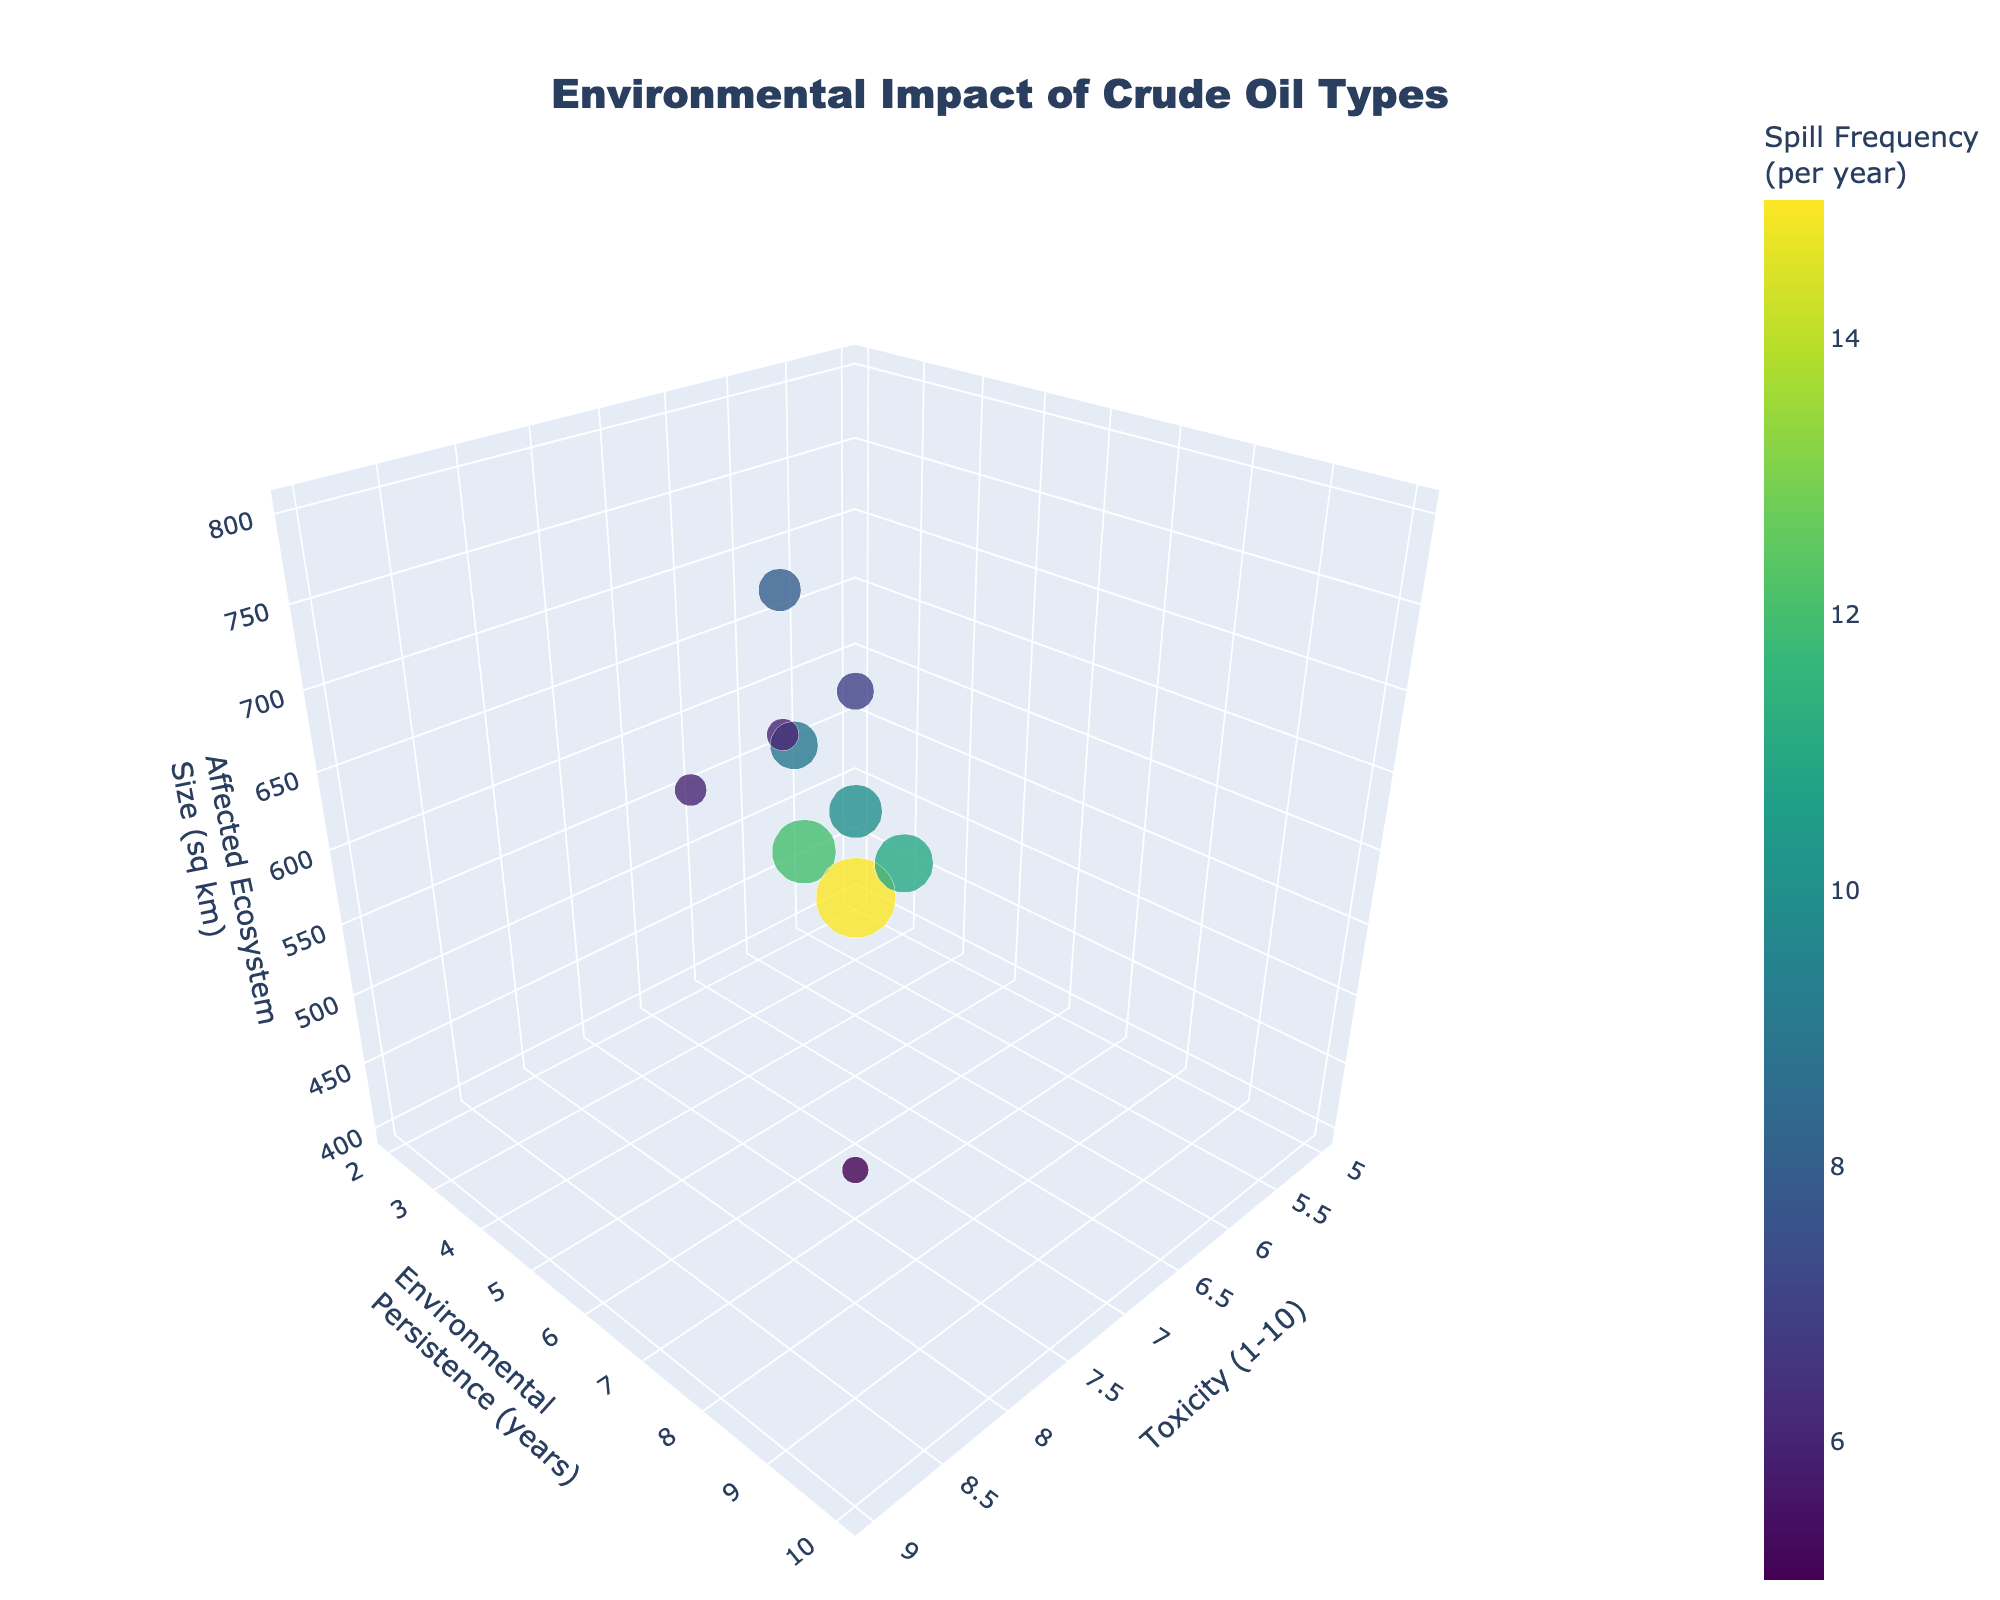What is the title of the figure? The title is clearly displayed at the top center of the figure.
Answer: Environmental Impact of Crude Oil Types Which crude oil type has the highest toxicity? By examining the x-axis labeled "Toxicity (1-10)", the data point furthest to the right represents the highest toxicity.
Answer: Bitumen What is the environmental persistence of the crude oil type with the highest spill frequency? Locate the largest bubble, then refer to its y-axis position labeled "Environmental Persistence (years)".
Answer: West Texas Intermediate has 2 years Which crude oil type affects the largest ecosystem size and what is that size? By examining the z-axis labeled "Affected Ecosystem Size (sq km)", the data point with the highest value is identified.
Answer: Heavy Sour Crude, 800 sq km Which crude oil type has lower toxicity, Nigerian Bonny Light or Brent Crude? Compare the positions along the x-axis for these two oil types. Nigerian Bonny Light is at x=5 and Brent Crude at x=6.
Answer: Nigerian Bonny Light What is the average environmental persistence of Brent Crude and Saudi Arabian Light? Average their y-axis values: (4+5)/2 = 4.5.
Answer: 4.5 years How does the spill frequency of Iranian Heavy compare to Bitumen? Compare the size of the bubbles representing these oil types; larger bubbles indicate higher frequency.
Answer: Iranian Heavy has a higher spill frequency than Bitumen What is the relationship between toxicity and affected ecosystem size for Venezuelan Extra Heavy? Locate the Venezuelan Extra Heavy bubble and note its x and z positions: x=9 (high toxicity), z=750 (large ecosystem size).
Answer: High toxicity and large affected area Is there any crude oil type that has low toxicity but high environmental persistence? Look for data points with low x values and high y values.
Answer: No, there is no such crude oil type in the figure Which crude oil types are clustered around similar levels of environmental persistence and spill frequency? Identify bubbles with similar y-axis positions and sizes.
Answer: Iranian Heavy and Venezuelan Extra Heavy are clustered around persistence of 7-8 years and similar spill frequencies 